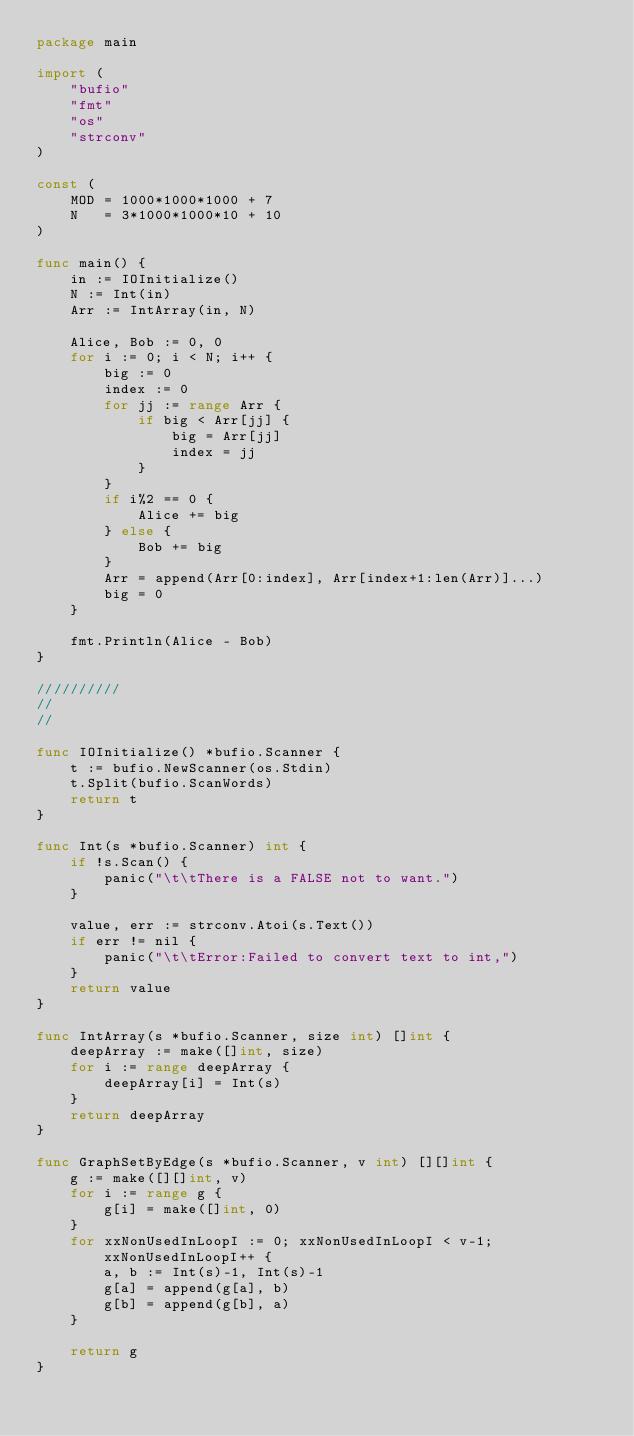Convert code to text. <code><loc_0><loc_0><loc_500><loc_500><_Go_>package main

import (
	"bufio"
	"fmt"
	"os"
	"strconv"
)

const (
	MOD = 1000*1000*1000 + 7
	N   = 3*1000*1000*10 + 10
)

func main() {
	in := IOInitialize()
	N := Int(in)
	Arr := IntArray(in, N)

	Alice, Bob := 0, 0
	for i := 0; i < N; i++ {
		big := 0
		index := 0
		for jj := range Arr {
			if big < Arr[jj] {
				big = Arr[jj]
				index = jj
			}
		}
		if i%2 == 0 {
			Alice += big
		} else {
			Bob += big
		}
		Arr = append(Arr[0:index], Arr[index+1:len(Arr)]...)
		big = 0
	}

	fmt.Println(Alice - Bob)
}

//////////
//
//

func IOInitialize() *bufio.Scanner {
	t := bufio.NewScanner(os.Stdin)
	t.Split(bufio.ScanWords)
	return t
}

func Int(s *bufio.Scanner) int {
	if !s.Scan() {
		panic("\t\tThere is a FALSE not to want.")
	}

	value, err := strconv.Atoi(s.Text())
	if err != nil {
		panic("\t\tError:Failed to convert text to int,")
	}
	return value
}

func IntArray(s *bufio.Scanner, size int) []int {
	deepArray := make([]int, size)
	for i := range deepArray {
		deepArray[i] = Int(s)
	}
	return deepArray
}

func GraphSetByEdge(s *bufio.Scanner, v int) [][]int {
	g := make([][]int, v)
	for i := range g {
		g[i] = make([]int, 0)
	}
	for xxNonUsedInLoopI := 0; xxNonUsedInLoopI < v-1; xxNonUsedInLoopI++ {
		a, b := Int(s)-1, Int(s)-1
		g[a] = append(g[a], b)
		g[b] = append(g[b], a)
	}

	return g
}
</code> 